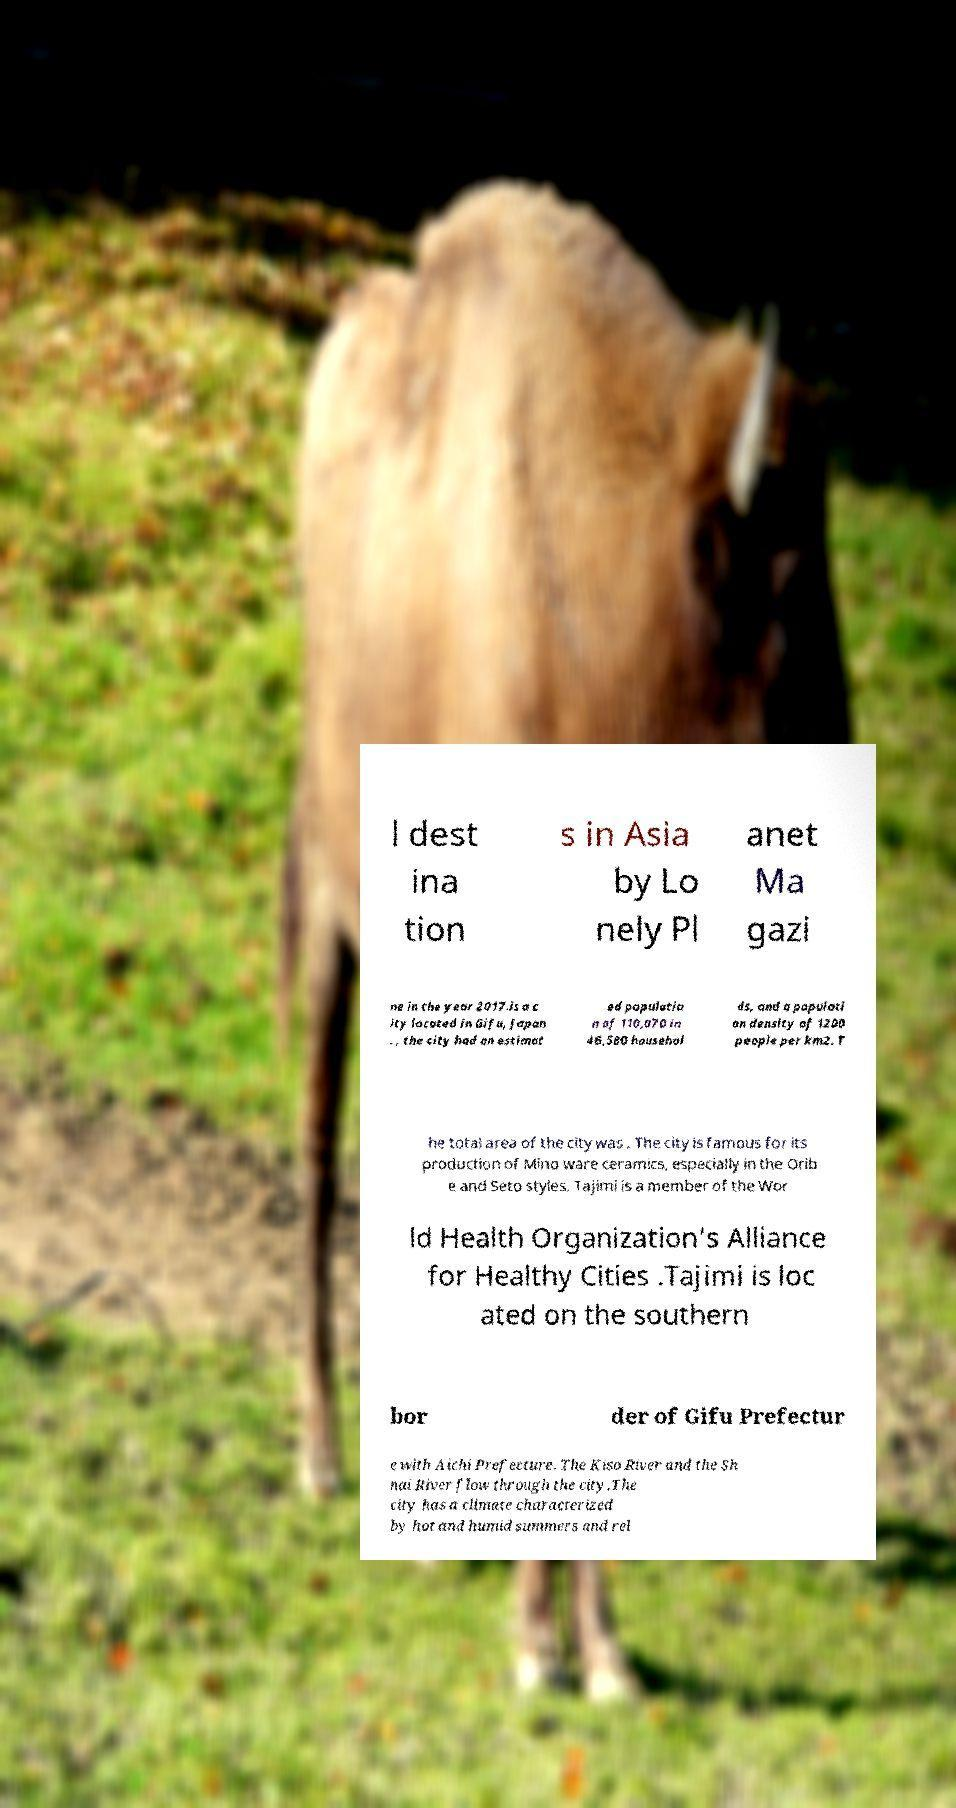Please read and relay the text visible in this image. What does it say? l dest ina tion s in Asia by Lo nely Pl anet Ma gazi ne in the year 2017.is a c ity located in Gifu, Japan . , the city had an estimat ed populatio n of 110,070 in 46,580 househol ds, and a populati on density of 1200 people per km2. T he total area of the city was . The city is famous for its production of Mino ware ceramics, especially in the Orib e and Seto styles. Tajimi is a member of the Wor ld Health Organization’s Alliance for Healthy Cities .Tajimi is loc ated on the southern bor der of Gifu Prefectur e with Aichi Prefecture. The Kiso River and the Sh nai River flow through the city.The city has a climate characterized by hot and humid summers and rel 